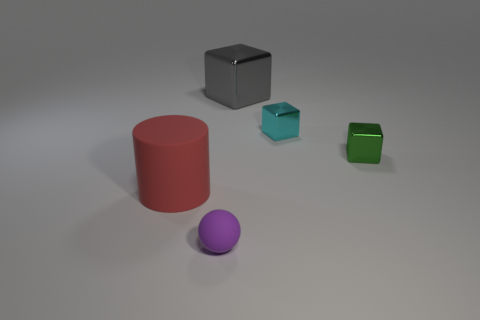There is a matte sphere; is it the same color as the large thing that is to the left of the small purple object?
Offer a terse response. No. What number of things are either rubber objects in front of the big red matte thing or small objects that are on the left side of the large block?
Your answer should be very brief. 1. Is the number of red things that are to the right of the big metal cube greater than the number of large gray blocks that are in front of the matte ball?
Ensure brevity in your answer.  No. What material is the small object to the left of the tiny metal block that is behind the tiny shiny cube that is in front of the small cyan block made of?
Your answer should be compact. Rubber. There is a shiny thing to the right of the cyan object; is it the same shape as the large object behind the rubber cylinder?
Provide a short and direct response. Yes. Is there a purple matte cube of the same size as the red rubber object?
Your answer should be compact. No. What number of purple objects are either small cubes or small matte balls?
Provide a succinct answer. 1. What number of small rubber balls are the same color as the big rubber thing?
Provide a short and direct response. 0. Is there anything else that is the same shape as the tiny cyan metal object?
Offer a terse response. Yes. How many balls are tiny purple rubber things or matte objects?
Give a very brief answer. 1. 